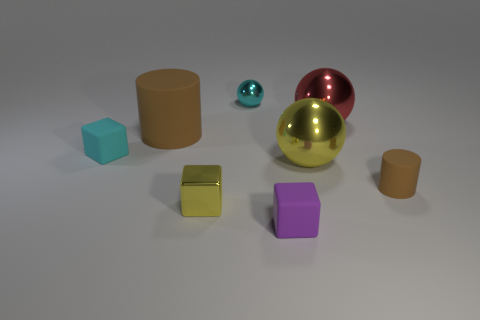What color is the tiny cube that is made of the same material as the small purple object?
Your answer should be compact. Cyan. What shape is the cyan shiny thing that is the same size as the purple rubber thing?
Ensure brevity in your answer.  Sphere. There is a tiny matte object that is both right of the small yellow shiny cube and behind the small metal block; what shape is it?
Keep it short and to the point. Cylinder. What shape is the other brown object that is the same material as the large brown thing?
Provide a succinct answer. Cylinder. Is there a cyan metal object?
Your answer should be very brief. Yes. There is a tiny cyan cube behind the tiny brown cylinder; are there any large brown objects that are in front of it?
Keep it short and to the point. No. There is a cyan object that is the same shape as the big red thing; what is its material?
Ensure brevity in your answer.  Metal. Are there more large blocks than small metallic cubes?
Give a very brief answer. No. There is a small shiny sphere; is its color the same as the tiny cube behind the small yellow cube?
Your answer should be compact. Yes. There is a tiny rubber object that is both left of the red metal sphere and right of the cyan rubber thing; what is its color?
Offer a terse response. Purple. 